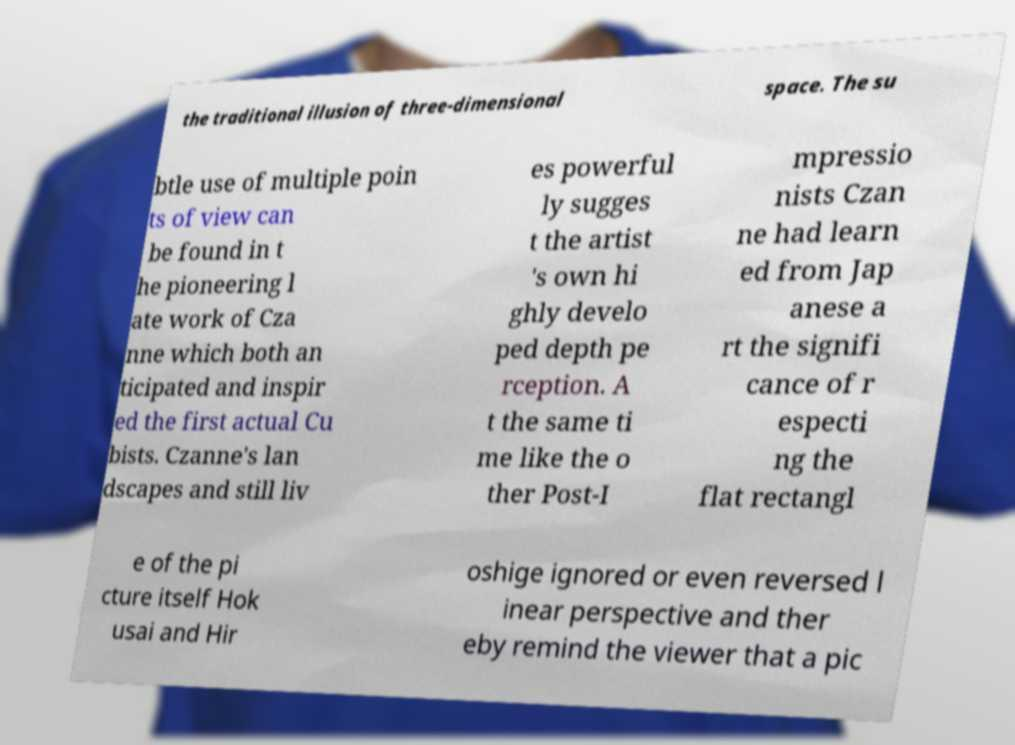Could you extract and type out the text from this image? the traditional illusion of three-dimensional space. The su btle use of multiple poin ts of view can be found in t he pioneering l ate work of Cza nne which both an ticipated and inspir ed the first actual Cu bists. Czanne's lan dscapes and still liv es powerful ly sugges t the artist 's own hi ghly develo ped depth pe rception. A t the same ti me like the o ther Post-I mpressio nists Czan ne had learn ed from Jap anese a rt the signifi cance of r especti ng the flat rectangl e of the pi cture itself Hok usai and Hir oshige ignored or even reversed l inear perspective and ther eby remind the viewer that a pic 